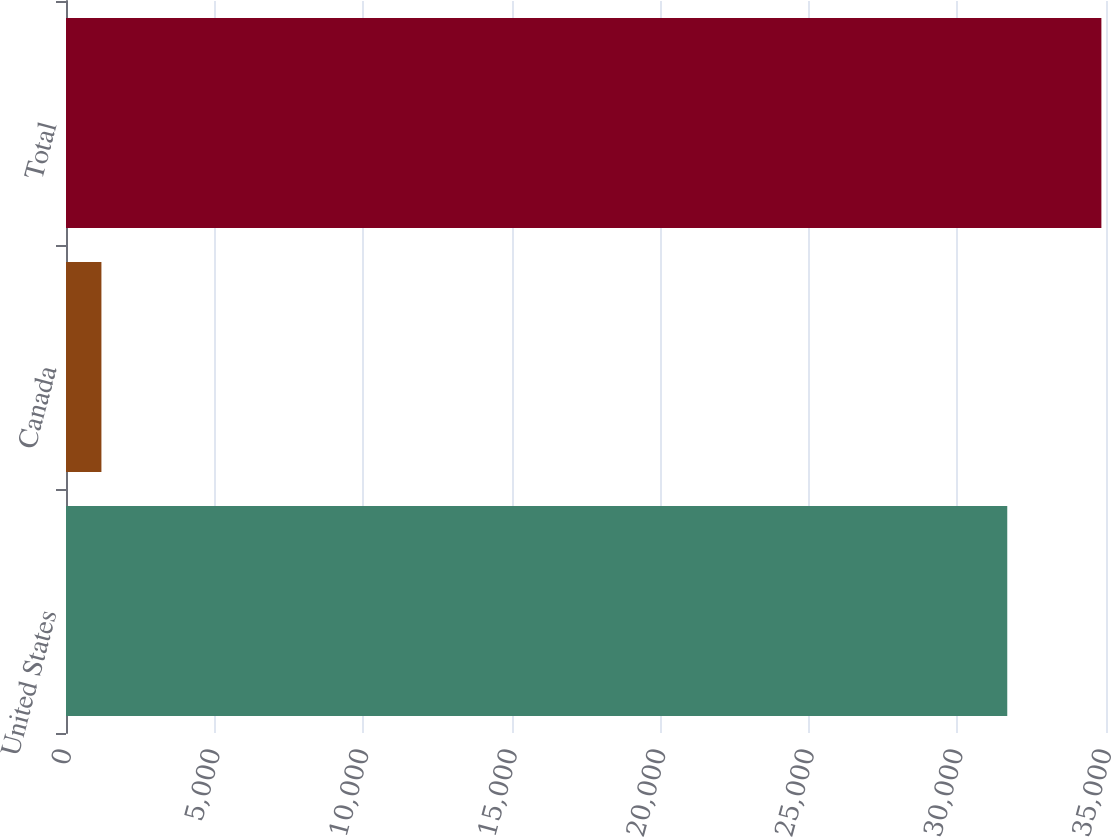<chart> <loc_0><loc_0><loc_500><loc_500><bar_chart><fcel>United States<fcel>Canada<fcel>Total<nl><fcel>31677<fcel>1192<fcel>34844.7<nl></chart> 